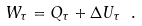<formula> <loc_0><loc_0><loc_500><loc_500>W _ { \tau } = Q _ { \tau } + \Delta U _ { \tau } \ .</formula> 